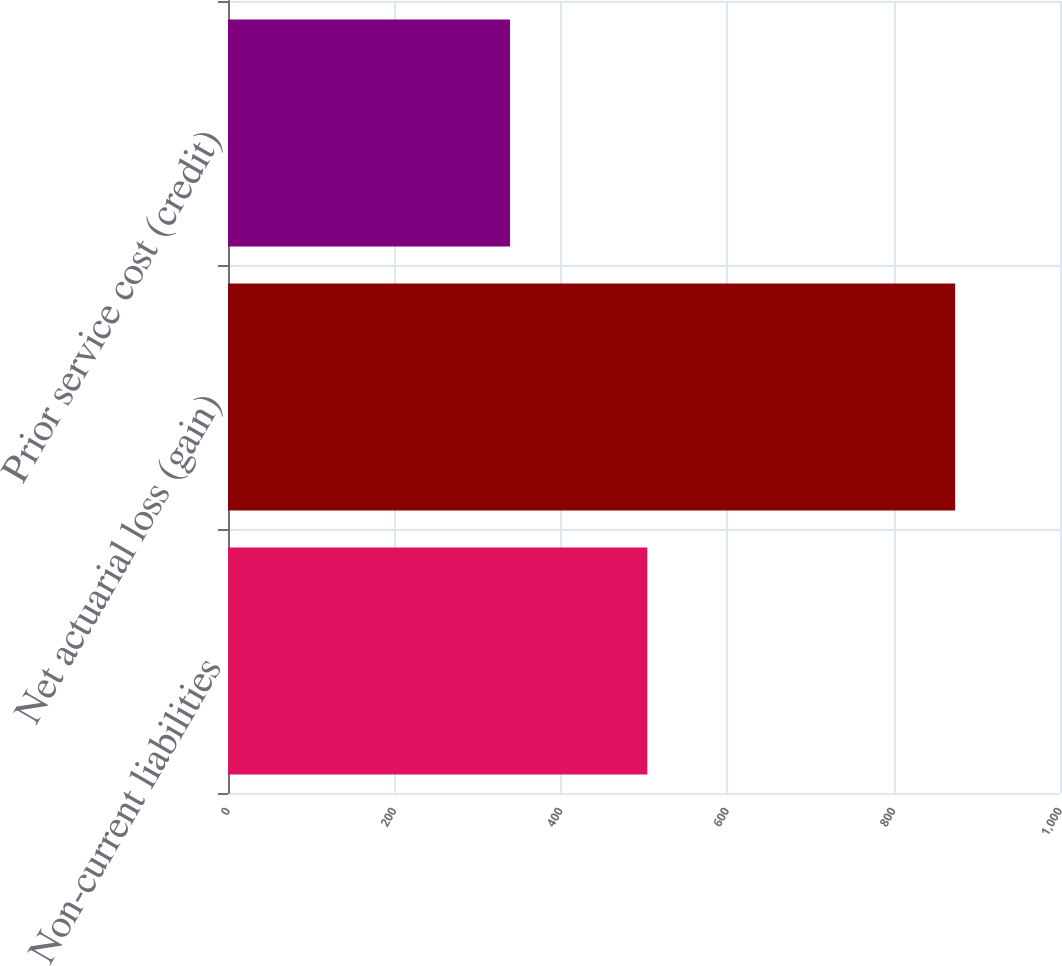<chart> <loc_0><loc_0><loc_500><loc_500><bar_chart><fcel>Non-current liabilities<fcel>Net actuarial loss (gain)<fcel>Prior service cost (credit)<nl><fcel>504<fcel>874<fcel>339<nl></chart> 